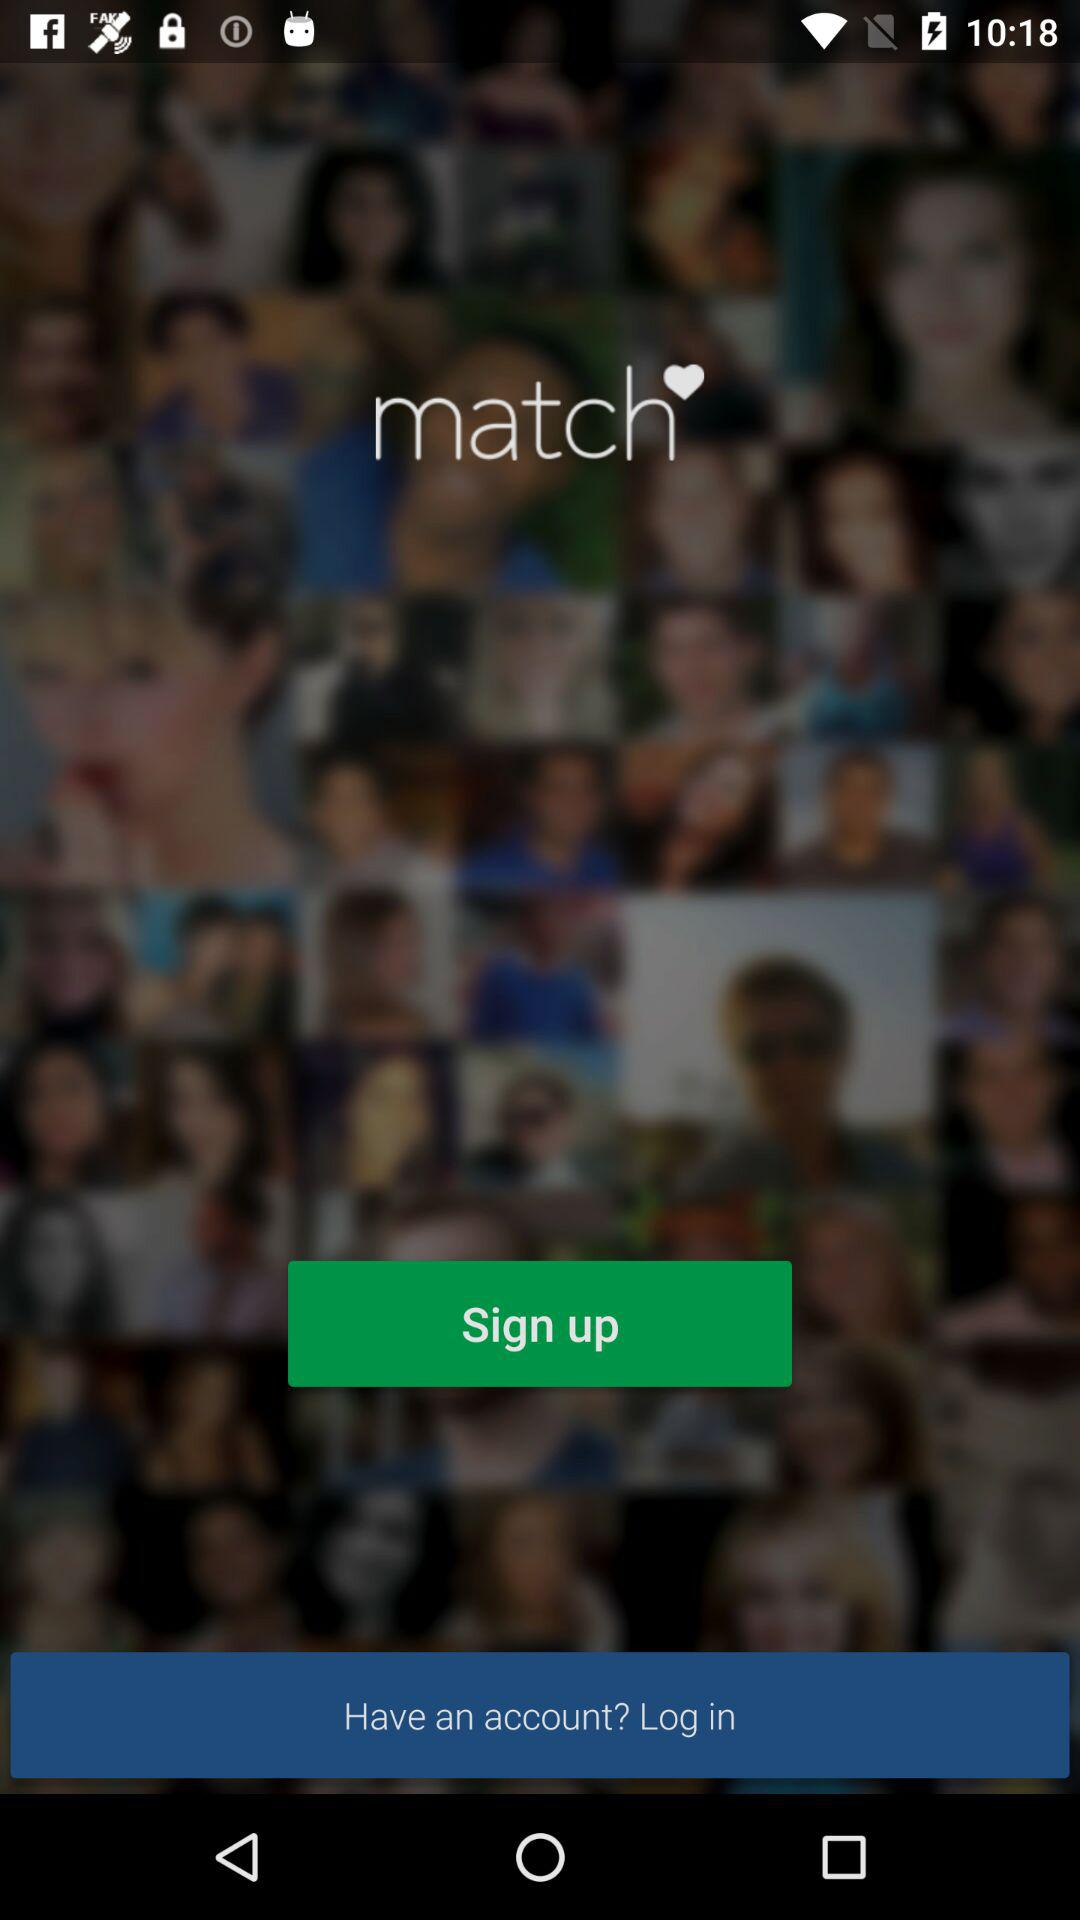What is the application name? The application name is "match". 